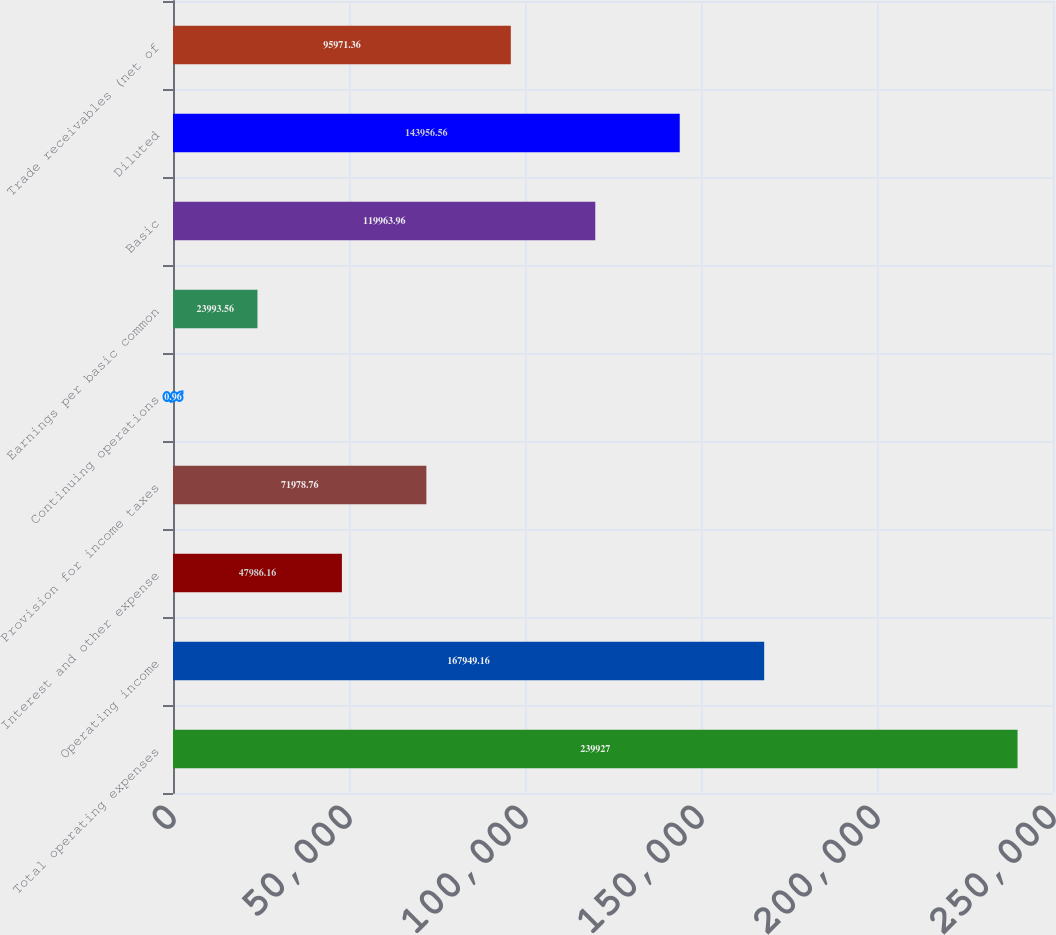<chart> <loc_0><loc_0><loc_500><loc_500><bar_chart><fcel>Total operating expenses<fcel>Operating income<fcel>Interest and other expense<fcel>Provision for income taxes<fcel>Continuing operations<fcel>Earnings per basic common<fcel>Basic<fcel>Diluted<fcel>Trade receivables (net of<nl><fcel>239927<fcel>167949<fcel>47986.2<fcel>71978.8<fcel>0.96<fcel>23993.6<fcel>119964<fcel>143957<fcel>95971.4<nl></chart> 